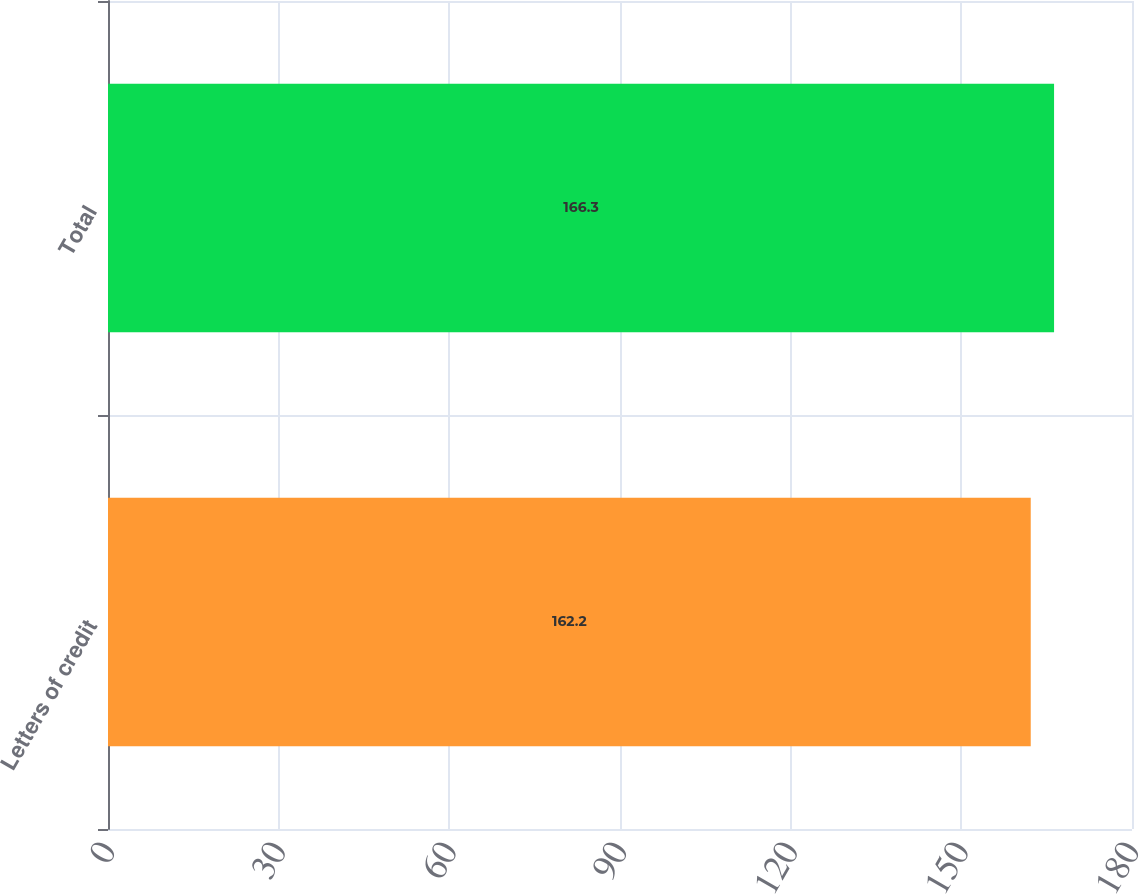Convert chart. <chart><loc_0><loc_0><loc_500><loc_500><bar_chart><fcel>Letters of credit<fcel>Total<nl><fcel>162.2<fcel>166.3<nl></chart> 